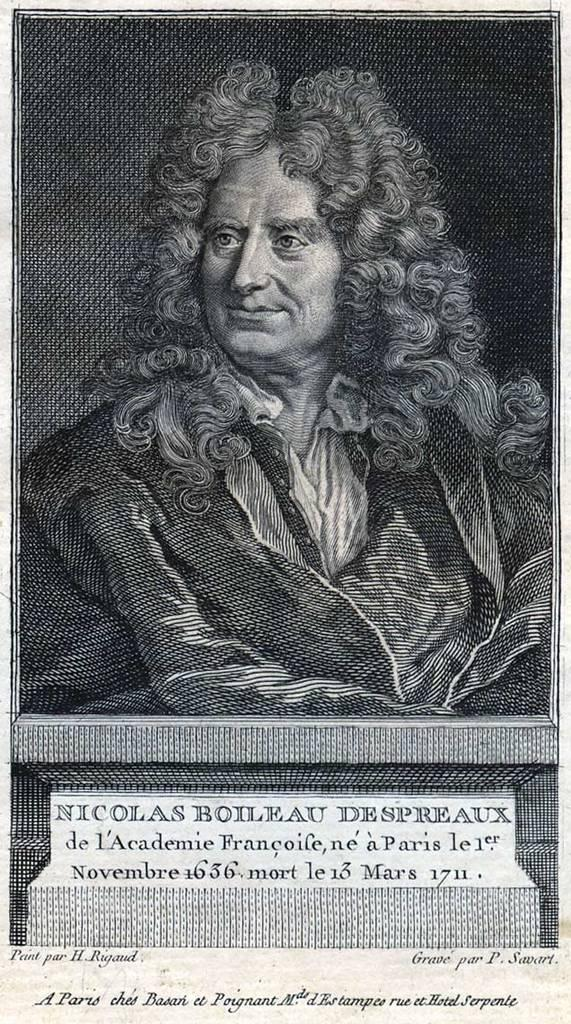What is the main subject of the image? The image contains a painting. What is depicted in the painting? The painting depicts a person. What is the person wearing in the painting? The person is wearing a dress in the painting. Can you describe the person's hair in the painting? The person has curly hair in the painting. What type of vacation is the person in the painting planning to take? There is no information about a vacation in the image or the painting. 